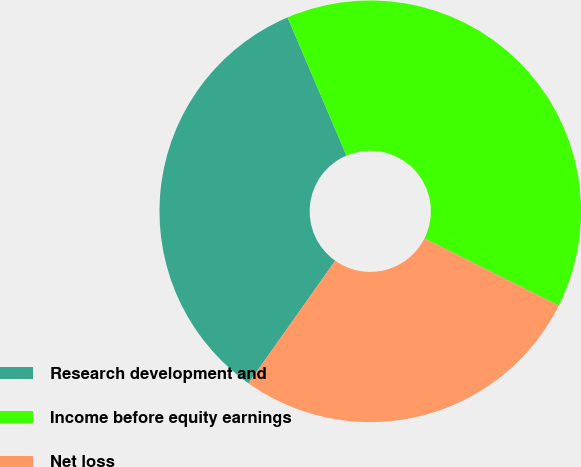Convert chart to OTSL. <chart><loc_0><loc_0><loc_500><loc_500><pie_chart><fcel>Research development and<fcel>Income before equity earnings<fcel>Net loss<nl><fcel>33.78%<fcel>38.8%<fcel>27.42%<nl></chart> 